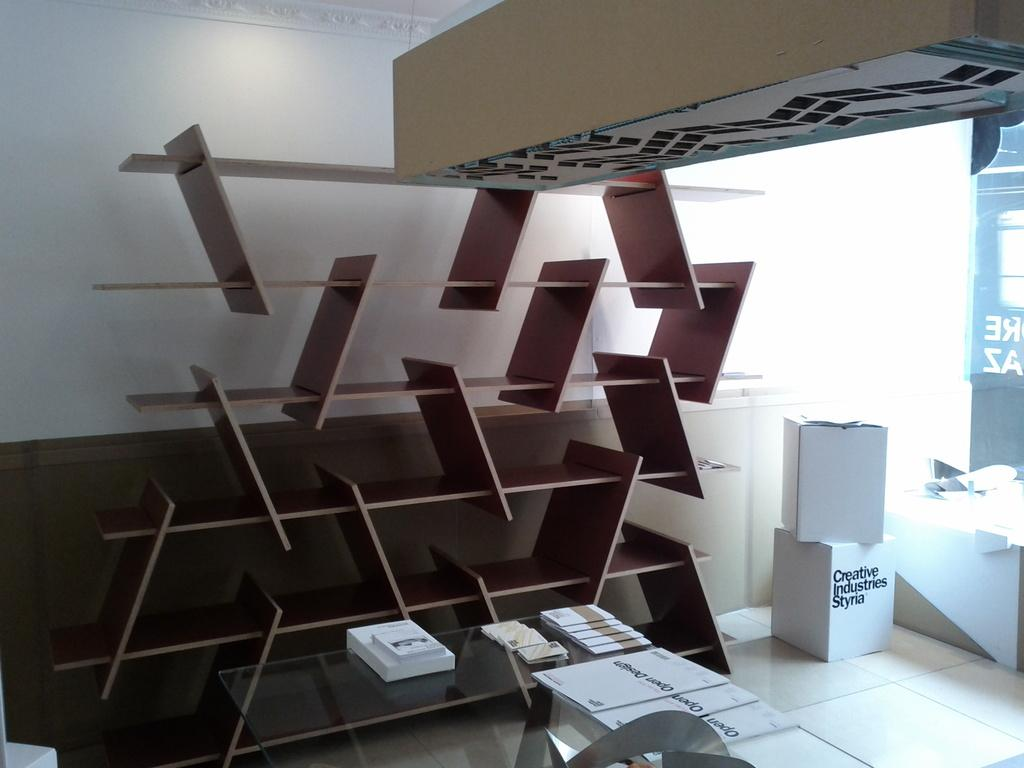What type of material is the cupboard made of in the image? The cupboard in the image is made of wood. What other furniture can be seen in the image? There is a table in the image. What is placed on the table in the image? Papers and cards are placed on the table in the image. What is visible in the background of the image? There is a wall in the background of the image. How many beds are visible in the image? There are no beds visible in the image. What type of cent is present in the image? There is no cent present in the image. 